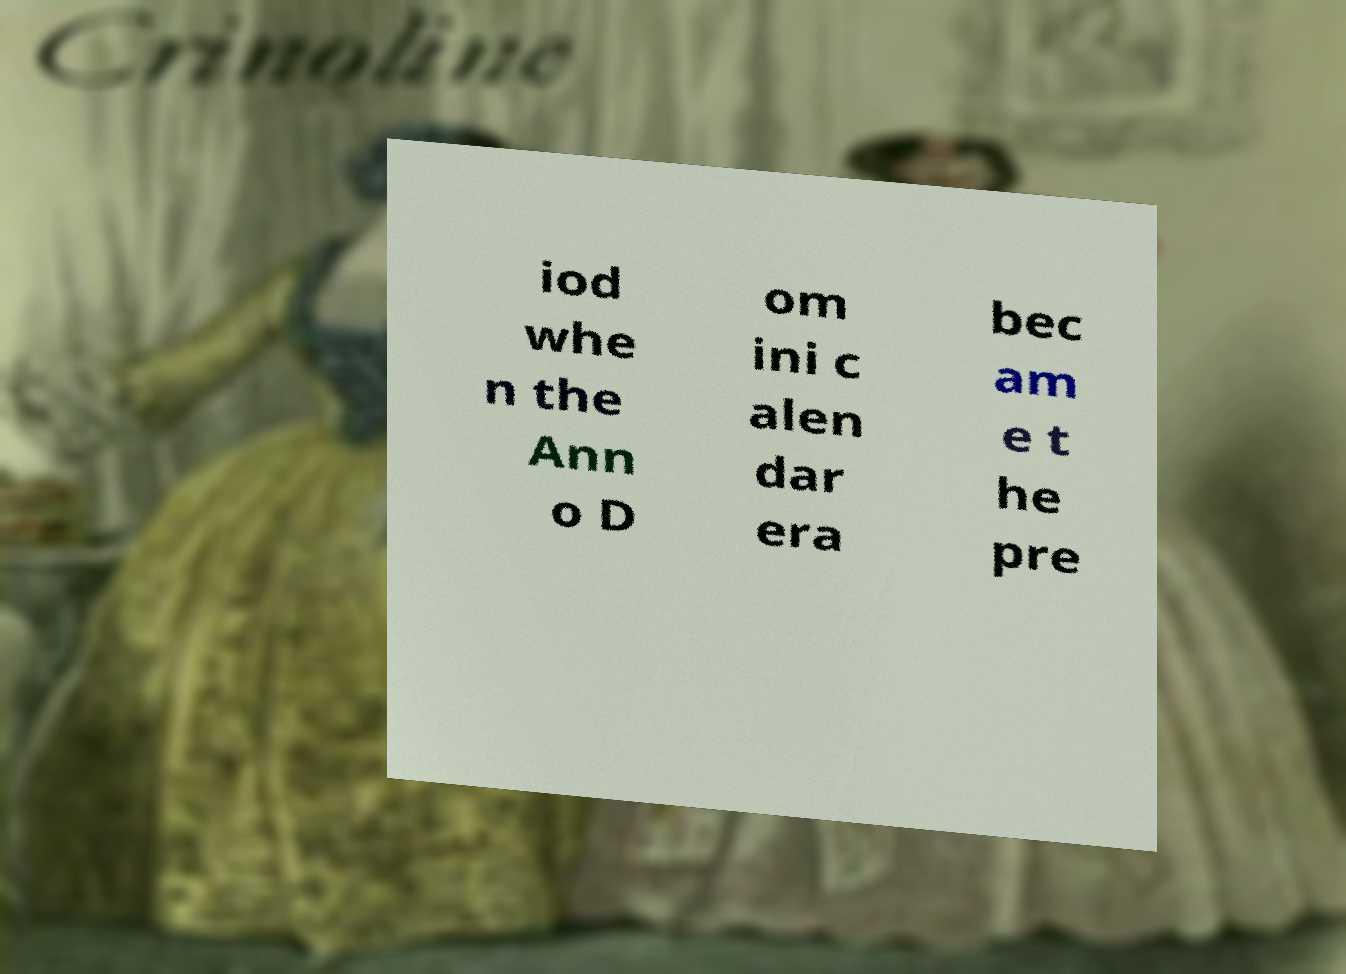I need the written content from this picture converted into text. Can you do that? iod whe n the Ann o D om ini c alen dar era bec am e t he pre 